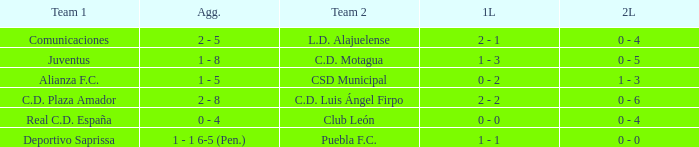What is the 1st leg where Team 1 is C.D. Plaza Amador? 2 - 2. 